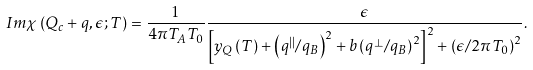<formula> <loc_0><loc_0><loc_500><loc_500>I m \chi \left ( { Q } _ { c } + { q } , \epsilon ; T \right ) = \frac { 1 } { 4 \pi T _ { A } T _ { 0 } } \frac { \epsilon } { \left [ y _ { Q } \left ( T \right ) + \left ( q ^ { | | } / q _ { B } \right ) ^ { 2 } + b \left ( { q } ^ { \bot } / q _ { B } \right ) ^ { 2 } \right ] ^ { 2 } + \left ( \epsilon / 2 \pi T _ { 0 } \right ) ^ { 2 } } .</formula> 